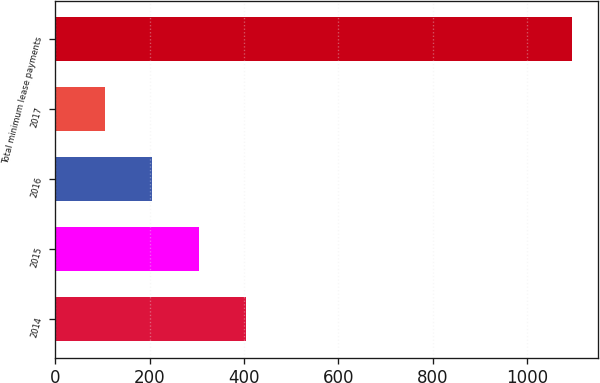Convert chart. <chart><loc_0><loc_0><loc_500><loc_500><bar_chart><fcel>2014<fcel>2015<fcel>2016<fcel>2017<fcel>Total minimum lease payments<nl><fcel>403<fcel>304<fcel>205<fcel>106<fcel>1096<nl></chart> 